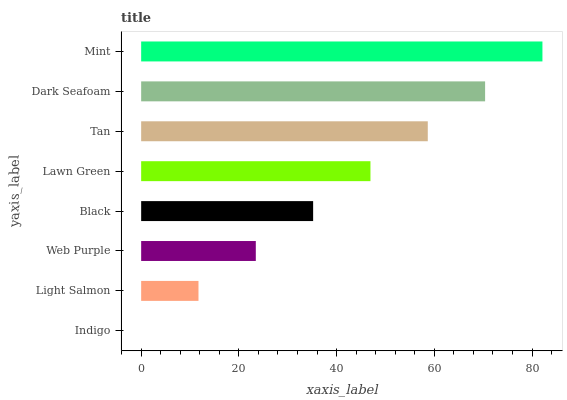Is Indigo the minimum?
Answer yes or no. Yes. Is Mint the maximum?
Answer yes or no. Yes. Is Light Salmon the minimum?
Answer yes or no. No. Is Light Salmon the maximum?
Answer yes or no. No. Is Light Salmon greater than Indigo?
Answer yes or no. Yes. Is Indigo less than Light Salmon?
Answer yes or no. Yes. Is Indigo greater than Light Salmon?
Answer yes or no. No. Is Light Salmon less than Indigo?
Answer yes or no. No. Is Lawn Green the high median?
Answer yes or no. Yes. Is Black the low median?
Answer yes or no. Yes. Is Dark Seafoam the high median?
Answer yes or no. No. Is Web Purple the low median?
Answer yes or no. No. 